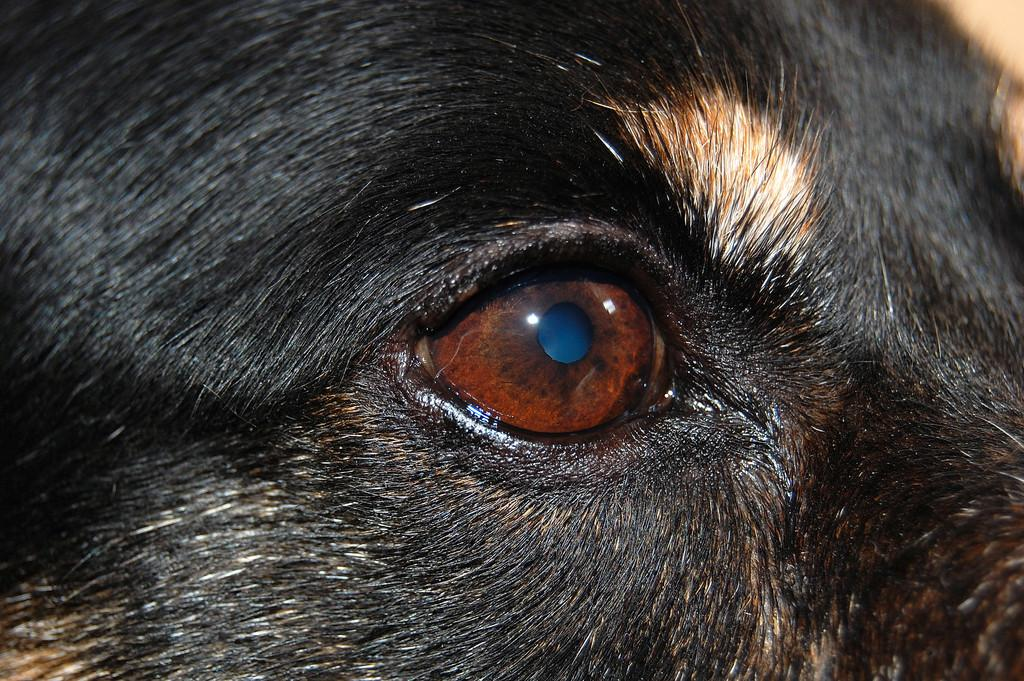What is the main subject of the image? The main subject of the image is a dog's eye. What colors can be seen in the dog's fur in the image? White and black hairs are visible at the top of the image. What advice does the dog's grandmother give in the image? There is no dog's grandmother present in the image, nor is there any advice being given. 